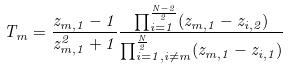Convert formula to latex. <formula><loc_0><loc_0><loc_500><loc_500>T _ { m } = \frac { z _ { m , 1 } - 1 } { z _ { m , 1 } ^ { 2 } + 1 } \frac { \prod _ { i = 1 } ^ { \frac { N - 2 } { 2 } } ( z _ { m , 1 } - z _ { i , 2 } ) } { \prod _ { i = 1 , i \neq m } ^ { \frac { N } { 2 } } ( z _ { m , 1 } - z _ { i , 1 } ) }</formula> 